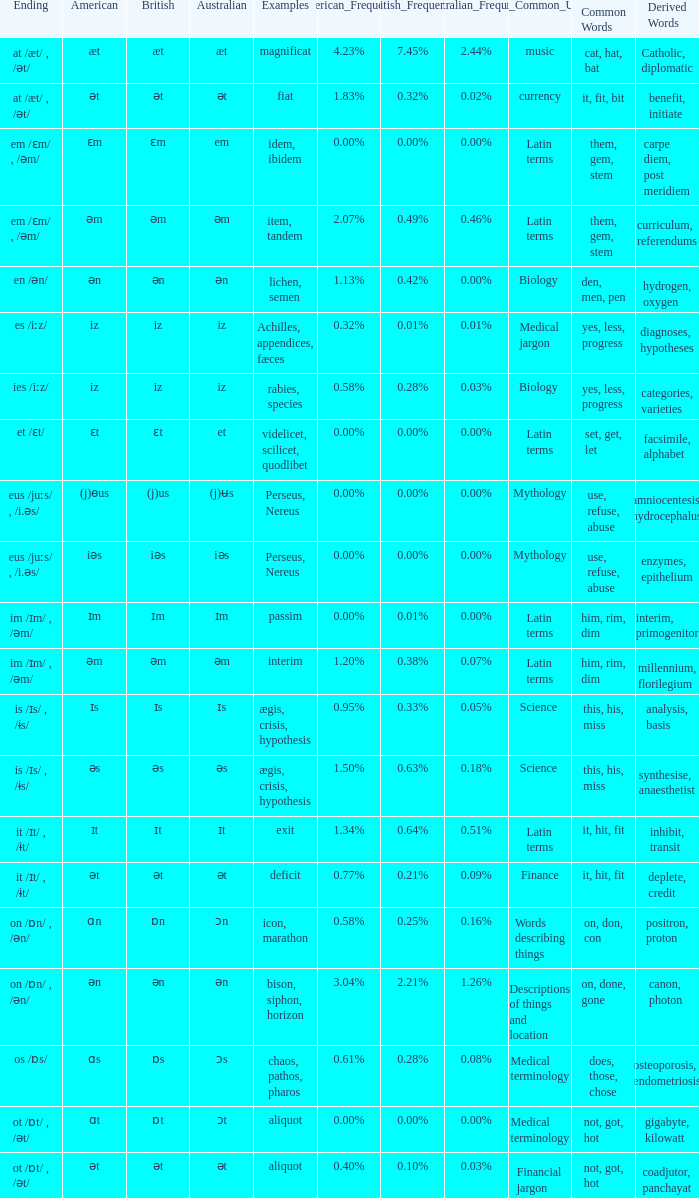Which British has Examples of exit? Ɪt. 